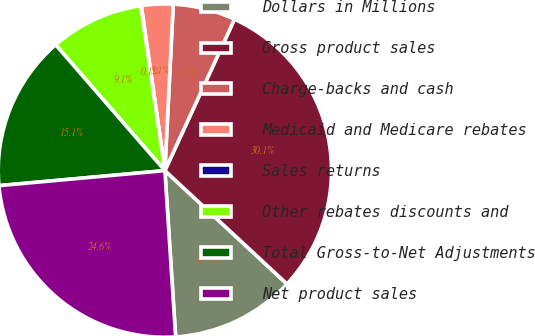Convert chart to OTSL. <chart><loc_0><loc_0><loc_500><loc_500><pie_chart><fcel>Dollars in Millions<fcel>Gross product sales<fcel>Charge-backs and cash<fcel>Medicaid and Medicare rebates<fcel>Sales returns<fcel>Other rebates discounts and<fcel>Total Gross-to-Net Adjustments<fcel>Net product sales<nl><fcel>12.06%<fcel>30.05%<fcel>6.06%<fcel>3.06%<fcel>0.06%<fcel>9.06%<fcel>15.06%<fcel>24.59%<nl></chart> 